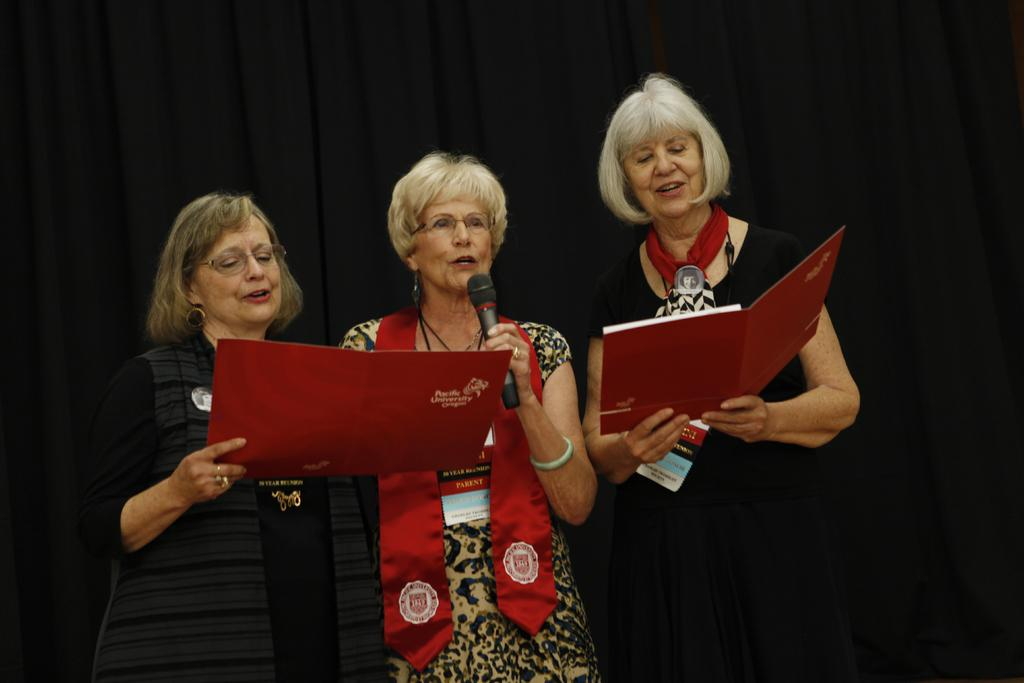How many women are in the image? There are three women in the image. Where are the women located in the image? The women are standing on a stage in the image. What are the women doing in the image? The women are singing into microphones and holding cards in their hands. What type of clam is being used as a prop by one of the women in the image? There are no clams present in the image; the women are holding cards, not clams. 